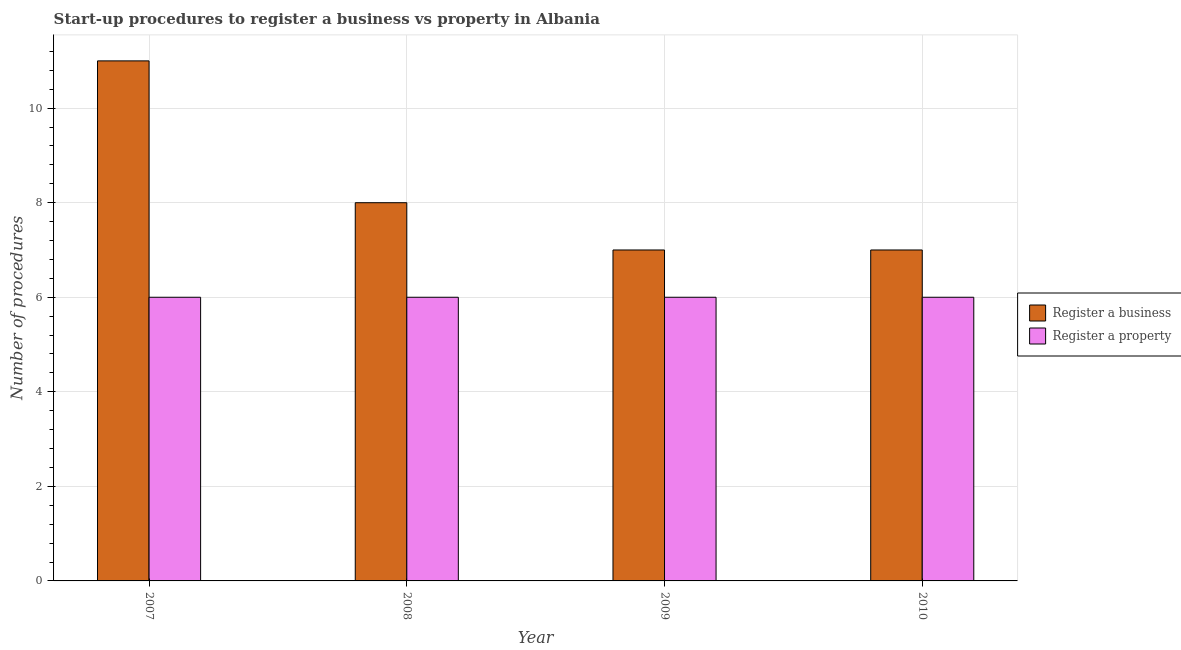How many groups of bars are there?
Your response must be concise. 4. Are the number of bars per tick equal to the number of legend labels?
Ensure brevity in your answer.  Yes. Are the number of bars on each tick of the X-axis equal?
Your answer should be very brief. Yes. How many bars are there on the 1st tick from the left?
Make the answer very short. 2. What is the number of procedures to register a property in 2010?
Your response must be concise. 6. Across all years, what is the minimum number of procedures to register a business?
Your answer should be very brief. 7. In which year was the number of procedures to register a property minimum?
Provide a short and direct response. 2007. What is the total number of procedures to register a property in the graph?
Your answer should be very brief. 24. What is the difference between the number of procedures to register a property in 2007 and that in 2010?
Offer a very short reply. 0. What is the difference between the number of procedures to register a business in 2008 and the number of procedures to register a property in 2010?
Provide a short and direct response. 1. What is the average number of procedures to register a business per year?
Your answer should be compact. 8.25. Is the number of procedures to register a business in 2008 less than that in 2009?
Offer a very short reply. No. Is the difference between the number of procedures to register a property in 2007 and 2010 greater than the difference between the number of procedures to register a business in 2007 and 2010?
Your answer should be compact. No. What is the difference between the highest and the lowest number of procedures to register a business?
Your response must be concise. 4. In how many years, is the number of procedures to register a property greater than the average number of procedures to register a property taken over all years?
Give a very brief answer. 0. Is the sum of the number of procedures to register a property in 2007 and 2009 greater than the maximum number of procedures to register a business across all years?
Your response must be concise. Yes. What does the 2nd bar from the left in 2010 represents?
Keep it short and to the point. Register a property. What does the 1st bar from the right in 2010 represents?
Your response must be concise. Register a property. How many bars are there?
Offer a terse response. 8. Are all the bars in the graph horizontal?
Make the answer very short. No. How many years are there in the graph?
Keep it short and to the point. 4. Are the values on the major ticks of Y-axis written in scientific E-notation?
Offer a very short reply. No. Does the graph contain grids?
Your answer should be very brief. Yes. Where does the legend appear in the graph?
Your response must be concise. Center right. How are the legend labels stacked?
Provide a succinct answer. Vertical. What is the title of the graph?
Make the answer very short. Start-up procedures to register a business vs property in Albania. What is the label or title of the X-axis?
Give a very brief answer. Year. What is the label or title of the Y-axis?
Provide a short and direct response. Number of procedures. What is the Number of procedures of Register a business in 2008?
Provide a succinct answer. 8. What is the Number of procedures of Register a property in 2008?
Provide a short and direct response. 6. What is the Number of procedures in Register a business in 2009?
Provide a short and direct response. 7. What is the Number of procedures of Register a property in 2009?
Give a very brief answer. 6. Across all years, what is the maximum Number of procedures of Register a business?
Provide a short and direct response. 11. What is the total Number of procedures of Register a business in the graph?
Your answer should be compact. 33. What is the total Number of procedures of Register a property in the graph?
Make the answer very short. 24. What is the difference between the Number of procedures in Register a business in 2007 and that in 2009?
Your answer should be very brief. 4. What is the difference between the Number of procedures of Register a property in 2007 and that in 2009?
Your response must be concise. 0. What is the difference between the Number of procedures of Register a property in 2008 and that in 2009?
Offer a terse response. 0. What is the difference between the Number of procedures of Register a business in 2008 and that in 2010?
Provide a short and direct response. 1. What is the difference between the Number of procedures of Register a property in 2008 and that in 2010?
Provide a short and direct response. 0. What is the difference between the Number of procedures of Register a business in 2009 and that in 2010?
Provide a short and direct response. 0. What is the difference between the Number of procedures of Register a property in 2009 and that in 2010?
Give a very brief answer. 0. What is the difference between the Number of procedures of Register a business in 2007 and the Number of procedures of Register a property in 2010?
Give a very brief answer. 5. What is the difference between the Number of procedures of Register a business in 2008 and the Number of procedures of Register a property in 2009?
Offer a very short reply. 2. What is the difference between the Number of procedures in Register a business in 2009 and the Number of procedures in Register a property in 2010?
Your answer should be very brief. 1. What is the average Number of procedures of Register a business per year?
Offer a terse response. 8.25. What is the average Number of procedures in Register a property per year?
Provide a short and direct response. 6. In the year 2007, what is the difference between the Number of procedures of Register a business and Number of procedures of Register a property?
Your answer should be compact. 5. In the year 2009, what is the difference between the Number of procedures of Register a business and Number of procedures of Register a property?
Provide a succinct answer. 1. What is the ratio of the Number of procedures in Register a business in 2007 to that in 2008?
Your answer should be compact. 1.38. What is the ratio of the Number of procedures in Register a business in 2007 to that in 2009?
Provide a short and direct response. 1.57. What is the ratio of the Number of procedures of Register a business in 2007 to that in 2010?
Offer a very short reply. 1.57. What is the ratio of the Number of procedures of Register a property in 2007 to that in 2010?
Offer a terse response. 1. What is the ratio of the Number of procedures in Register a business in 2008 to that in 2009?
Offer a terse response. 1.14. What is the ratio of the Number of procedures of Register a property in 2009 to that in 2010?
Provide a succinct answer. 1. What is the difference between the highest and the second highest Number of procedures of Register a business?
Provide a succinct answer. 3. What is the difference between the highest and the second highest Number of procedures of Register a property?
Provide a short and direct response. 0. What is the difference between the highest and the lowest Number of procedures of Register a property?
Provide a succinct answer. 0. 